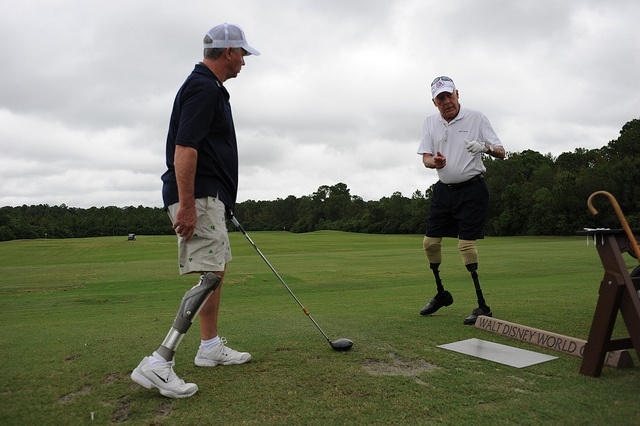Describe the objects in this image and their specific colors. I can see people in lavender, black, darkgray, gray, and maroon tones and people in lavender, black, darkgray, gray, and darkgreen tones in this image. 